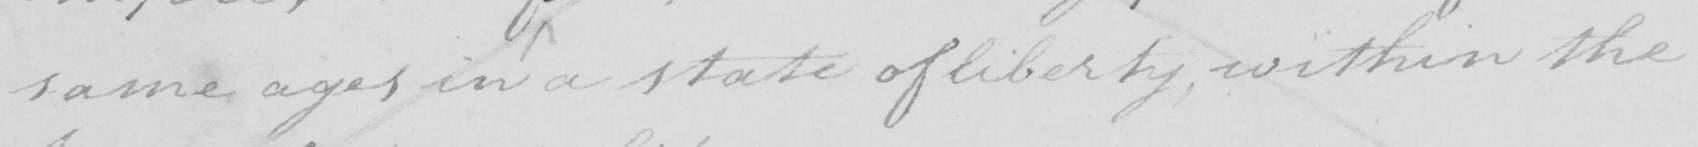What text is written in this handwritten line? same ages in a state of liberty , within the 